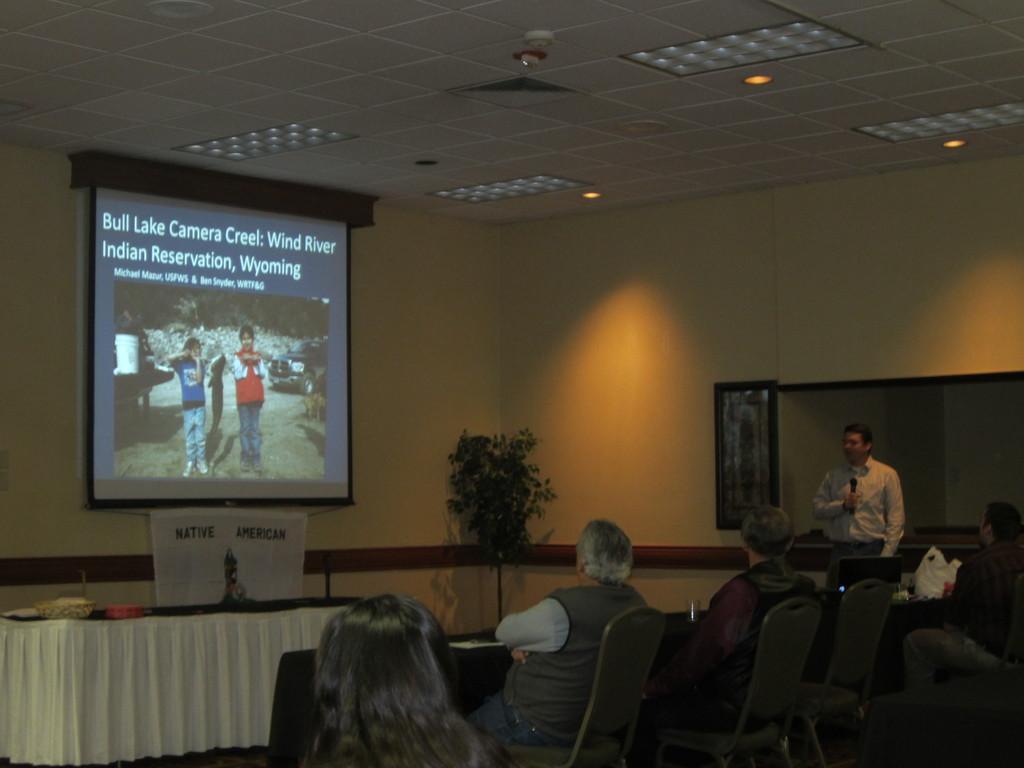In one or two sentences, can you explain what this image depicts? In this picture we can see some persons are sitting on the chairs. This is table and there is a cloth. Here we can see a man who is standing on the floor. This is plant. On the background there is a wall. Here we can see a screen and these are the lights. 